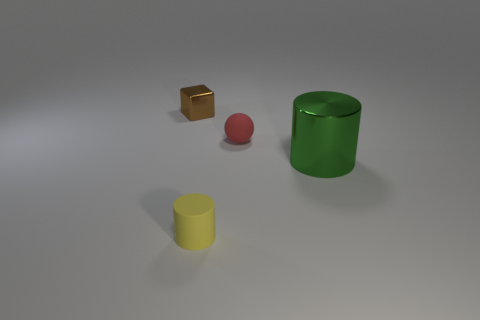Subtract all red cylinders. Subtract all green spheres. How many cylinders are left? 2 Add 3 purple matte cubes. How many objects exist? 7 Subtract all spheres. How many objects are left? 3 Add 4 big green shiny balls. How many big green shiny balls exist? 4 Subtract 0 gray cylinders. How many objects are left? 4 Subtract all tiny red balls. Subtract all cylinders. How many objects are left? 1 Add 3 tiny yellow things. How many tiny yellow things are left? 4 